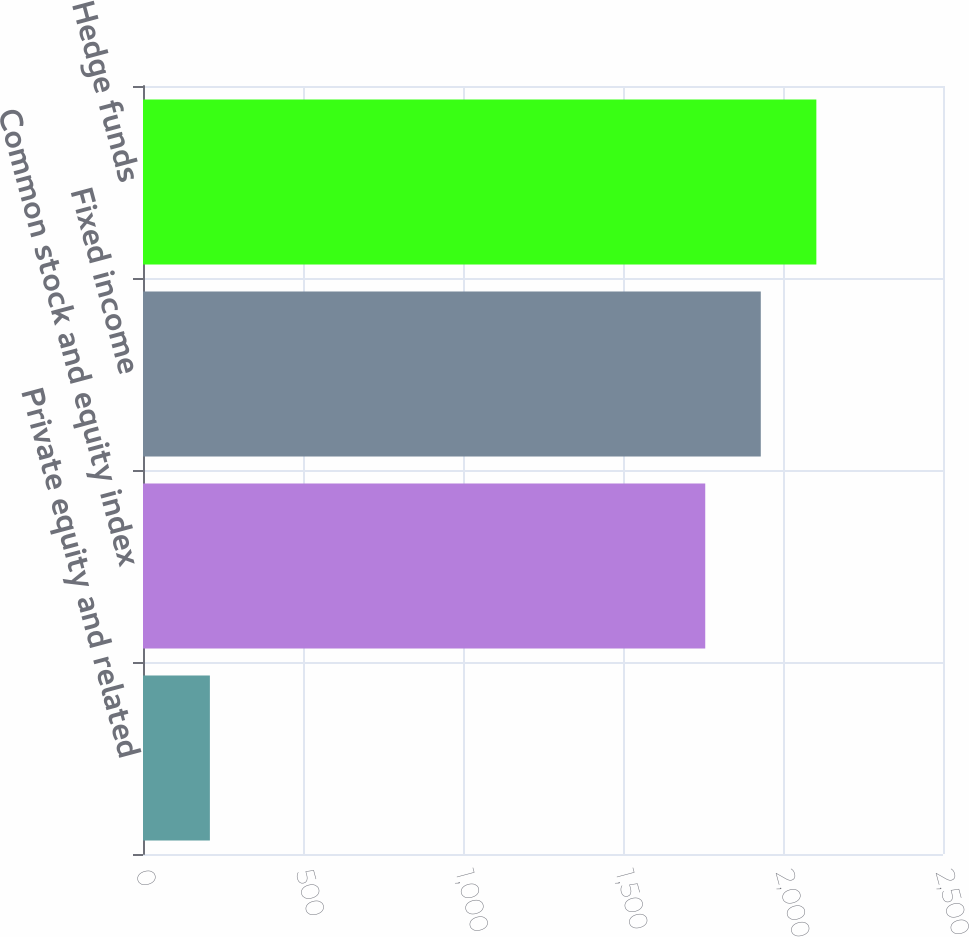Convert chart to OTSL. <chart><loc_0><loc_0><loc_500><loc_500><bar_chart><fcel>Private equity and related<fcel>Common stock and equity index<fcel>Fixed income<fcel>Hedge funds<nl><fcel>209<fcel>1757<fcel>1930.6<fcel>2104.2<nl></chart> 